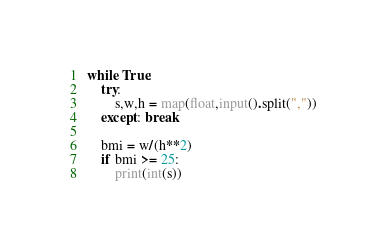Convert code to text. <code><loc_0><loc_0><loc_500><loc_500><_Python_>while True:    
    try:
        s,w,h = map(float,input().split(","))
    except: break

    bmi = w/(h**2)
    if bmi >= 25:
        print(int(s))
</code> 